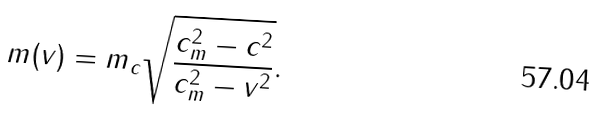<formula> <loc_0><loc_0><loc_500><loc_500>m ( v ) = m _ { c } \sqrt { \frac { c _ { m } ^ { 2 } - c ^ { 2 } } { c _ { m } ^ { 2 } - v ^ { 2 } } } .</formula> 